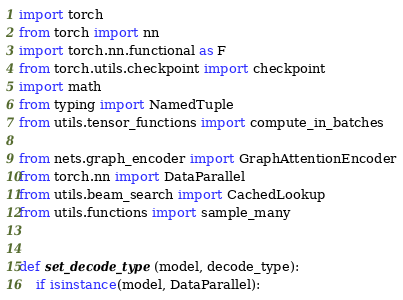<code> <loc_0><loc_0><loc_500><loc_500><_Python_>import torch
from torch import nn
import torch.nn.functional as F
from torch.utils.checkpoint import checkpoint
import math
from typing import NamedTuple
from utils.tensor_functions import compute_in_batches

from nets.graph_encoder import GraphAttentionEncoder
from torch.nn import DataParallel
from utils.beam_search import CachedLookup
from utils.functions import sample_many


def set_decode_type(model, decode_type):
    if isinstance(model, DataParallel):</code> 